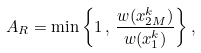Convert formula to latex. <formula><loc_0><loc_0><loc_500><loc_500>A _ { R } = \min \left \{ 1 \, , \, \frac { w ( x _ { 2 M } ^ { k } ) } { w ( x _ { 1 } ^ { k } ) } \right \} ,</formula> 